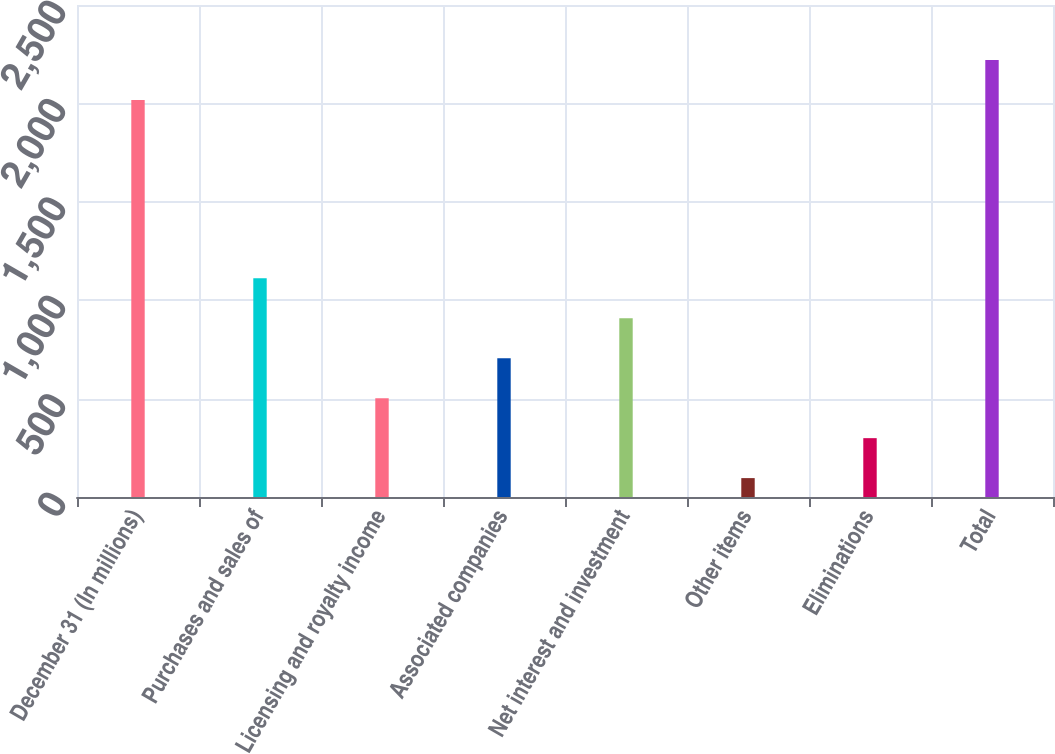Convert chart to OTSL. <chart><loc_0><loc_0><loc_500><loc_500><bar_chart><fcel>December 31 (In millions)<fcel>Purchases and sales of<fcel>Licensing and royalty income<fcel>Associated companies<fcel>Net interest and investment<fcel>Other items<fcel>Eliminations<fcel>Total<nl><fcel>2017<fcel>1111<fcel>502<fcel>705<fcel>908<fcel>96<fcel>299<fcel>2220<nl></chart> 